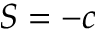Convert formula to latex. <formula><loc_0><loc_0><loc_500><loc_500>S = - c</formula> 